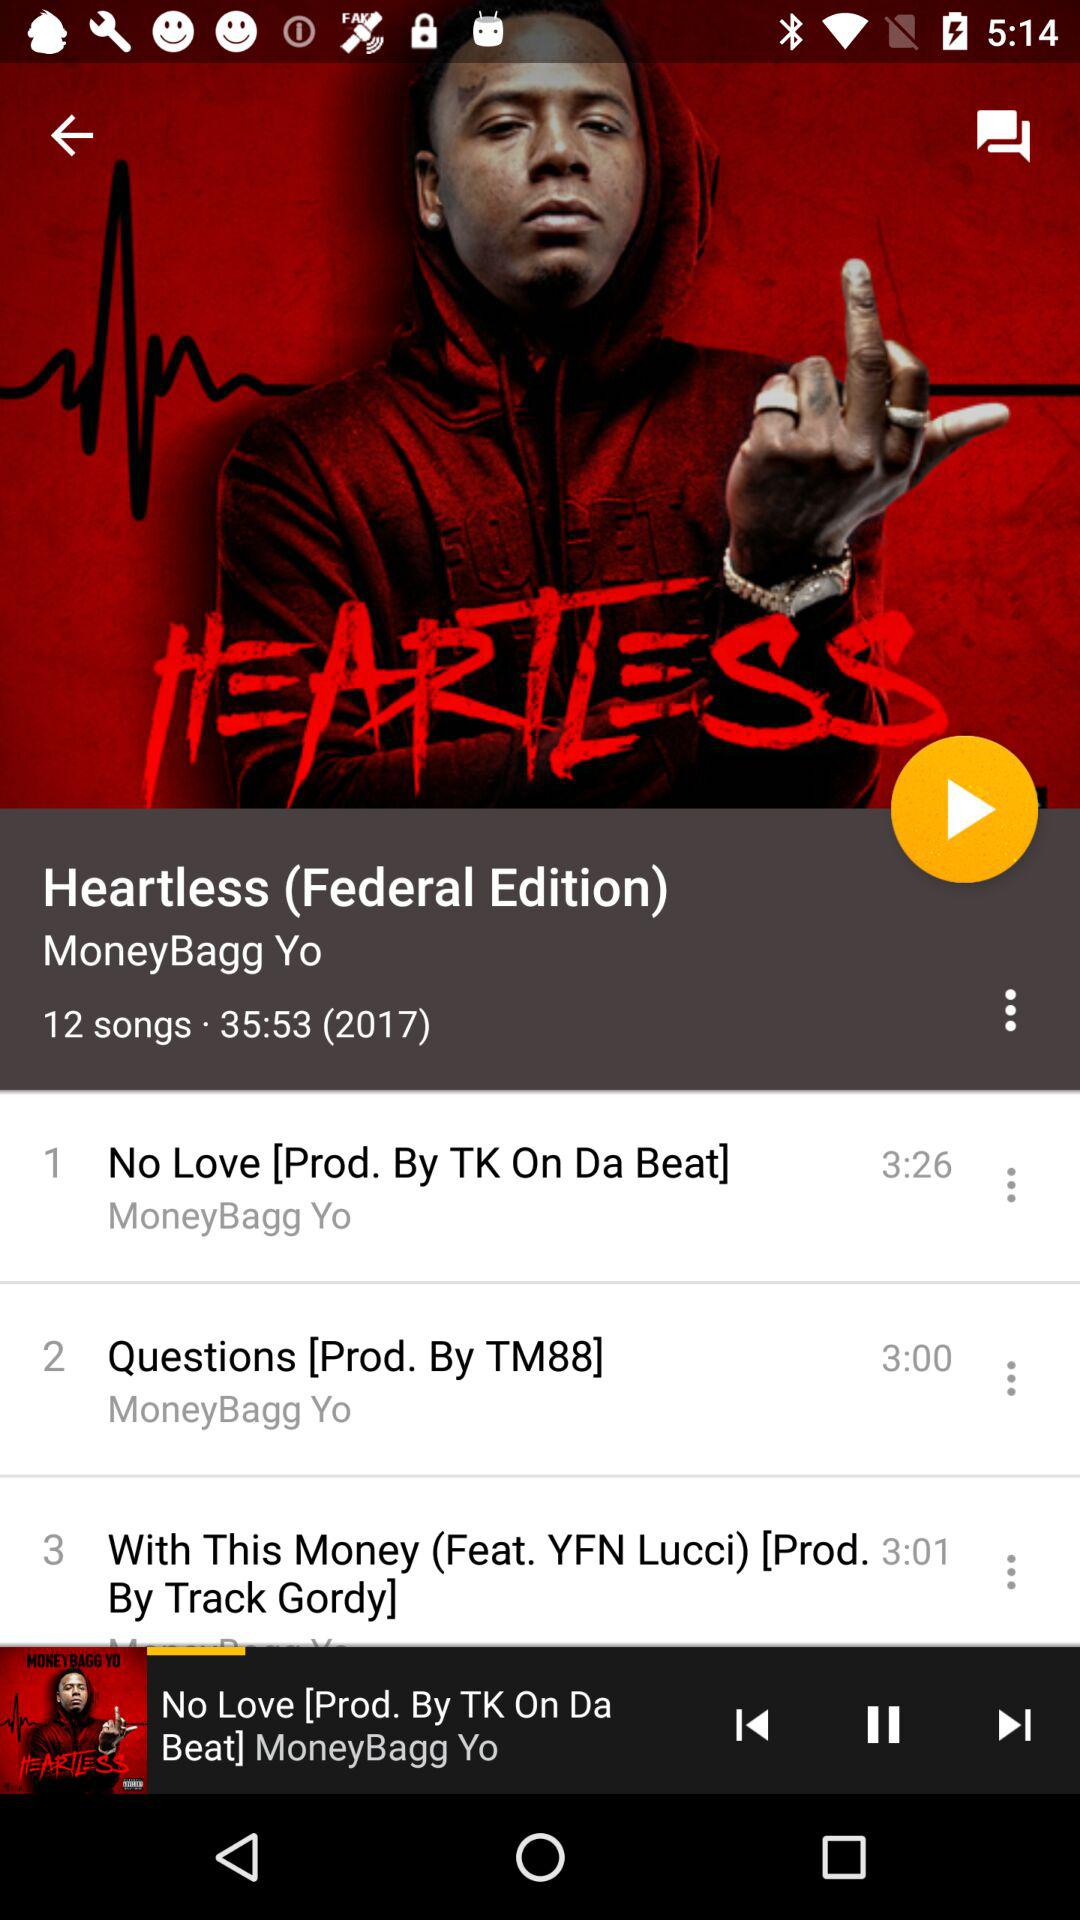What is the total length of all 12 songs? The total length of all 12 songs is 35 minutes and 53 seconds. 